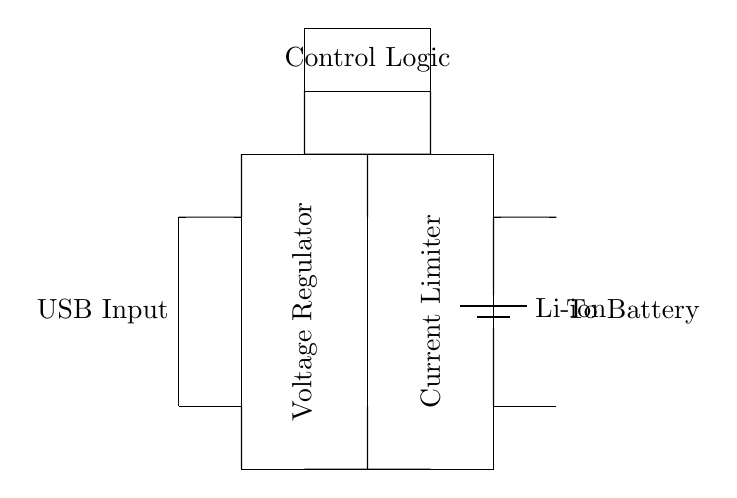What is the input source of this circuit? The input source of the circuit is specified as "USB Input" on the left side of the diagram, indicating the circuit is powered by a USB connection.
Answer: USB Input What type of battery is used in the circuit? The circuit diagram labels the battery explicitly as "Li-ion," indicating the specific type of battery used for storage.
Answer: Li-ion What component is responsible for voltage regulation? The circuit shows a rectangular component labeled "Voltage Regulator" located before the current limiter, which outlines its function of stabilizing the output voltage.
Answer: Voltage Regulator What is the purpose of the current limiter in the circuit? The current limiter is included to prevent over-current conditions that could damage the battery, ensuring safer charging by restricting the maximum current flow.
Answer: Prevent over-current How does the control logic interact with other components? The control logic connects to both the voltage regulator and the current limiter, allowing it to monitor and manage their operations to optimize charging conditions.
Answer: Monitoring and management What is the output of this circuit? The diagram indicates the output as "To Battery," showing that the purpose of this circuit is to charge a connected battery, built upon the regulated voltage and current management.
Answer: To Battery 